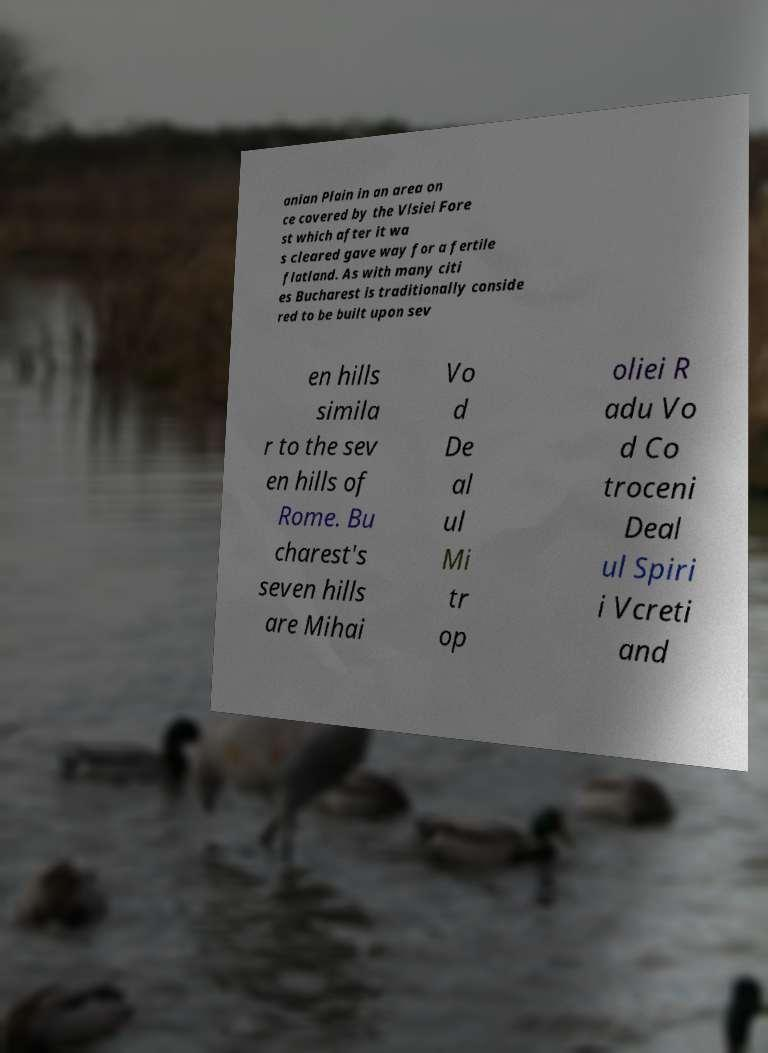I need the written content from this picture converted into text. Can you do that? anian Plain in an area on ce covered by the Vlsiei Fore st which after it wa s cleared gave way for a fertile flatland. As with many citi es Bucharest is traditionally conside red to be built upon sev en hills simila r to the sev en hills of Rome. Bu charest's seven hills are Mihai Vo d De al ul Mi tr op oliei R adu Vo d Co troceni Deal ul Spiri i Vcreti and 